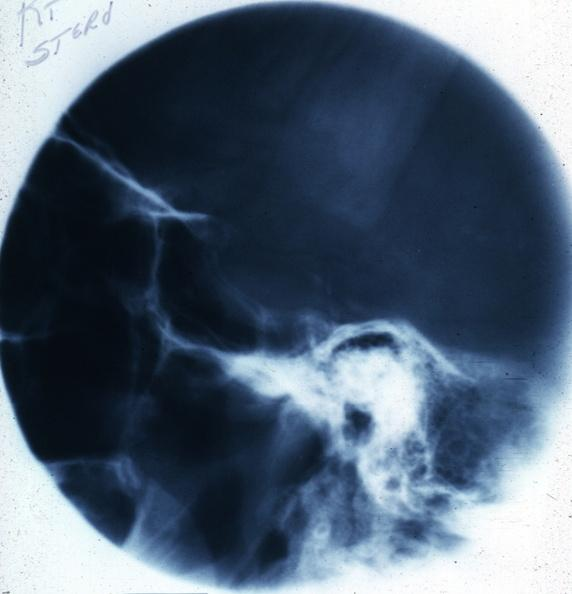s malignant adenoma present?
Answer the question using a single word or phrase. No 